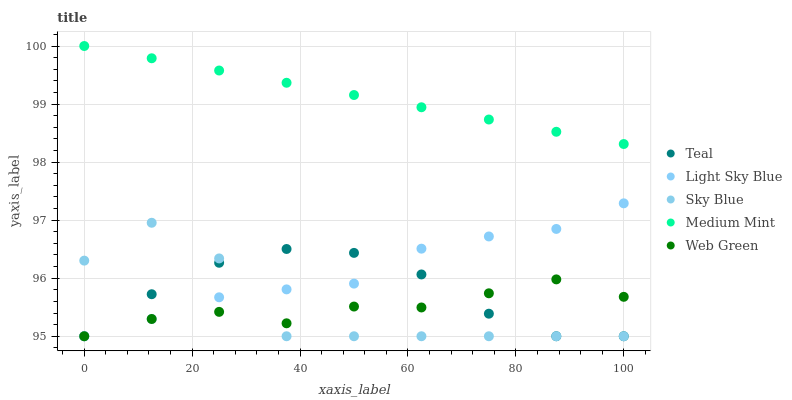Does Sky Blue have the minimum area under the curve?
Answer yes or no. Yes. Does Medium Mint have the maximum area under the curve?
Answer yes or no. Yes. Does Light Sky Blue have the minimum area under the curve?
Answer yes or no. No. Does Light Sky Blue have the maximum area under the curve?
Answer yes or no. No. Is Medium Mint the smoothest?
Answer yes or no. Yes. Is Sky Blue the roughest?
Answer yes or no. Yes. Is Light Sky Blue the smoothest?
Answer yes or no. No. Is Light Sky Blue the roughest?
Answer yes or no. No. Does Sky Blue have the lowest value?
Answer yes or no. Yes. Does Medium Mint have the highest value?
Answer yes or no. Yes. Does Sky Blue have the highest value?
Answer yes or no. No. Is Web Green less than Medium Mint?
Answer yes or no. Yes. Is Medium Mint greater than Sky Blue?
Answer yes or no. Yes. Does Teal intersect Web Green?
Answer yes or no. Yes. Is Teal less than Web Green?
Answer yes or no. No. Is Teal greater than Web Green?
Answer yes or no. No. Does Web Green intersect Medium Mint?
Answer yes or no. No. 